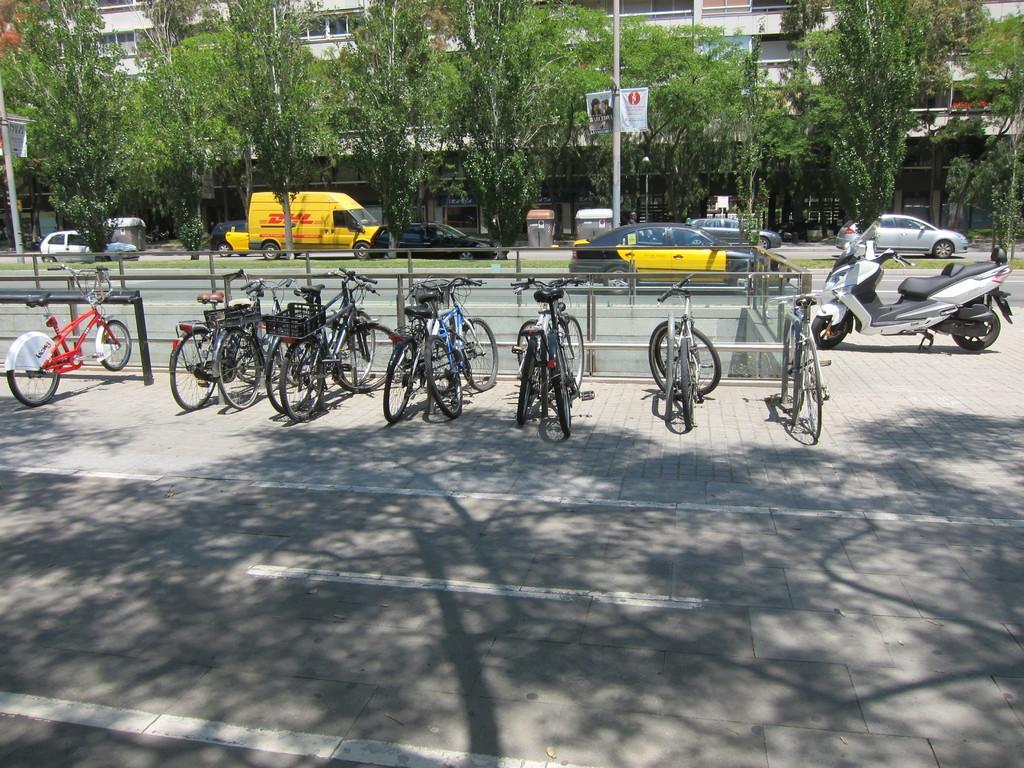Could you give a brief overview of what you see in this image? In this image in the center there are bicycles on the footpath and there is a bike. In the background there are cars moving on the road, there are trees, poles and there is a building. 